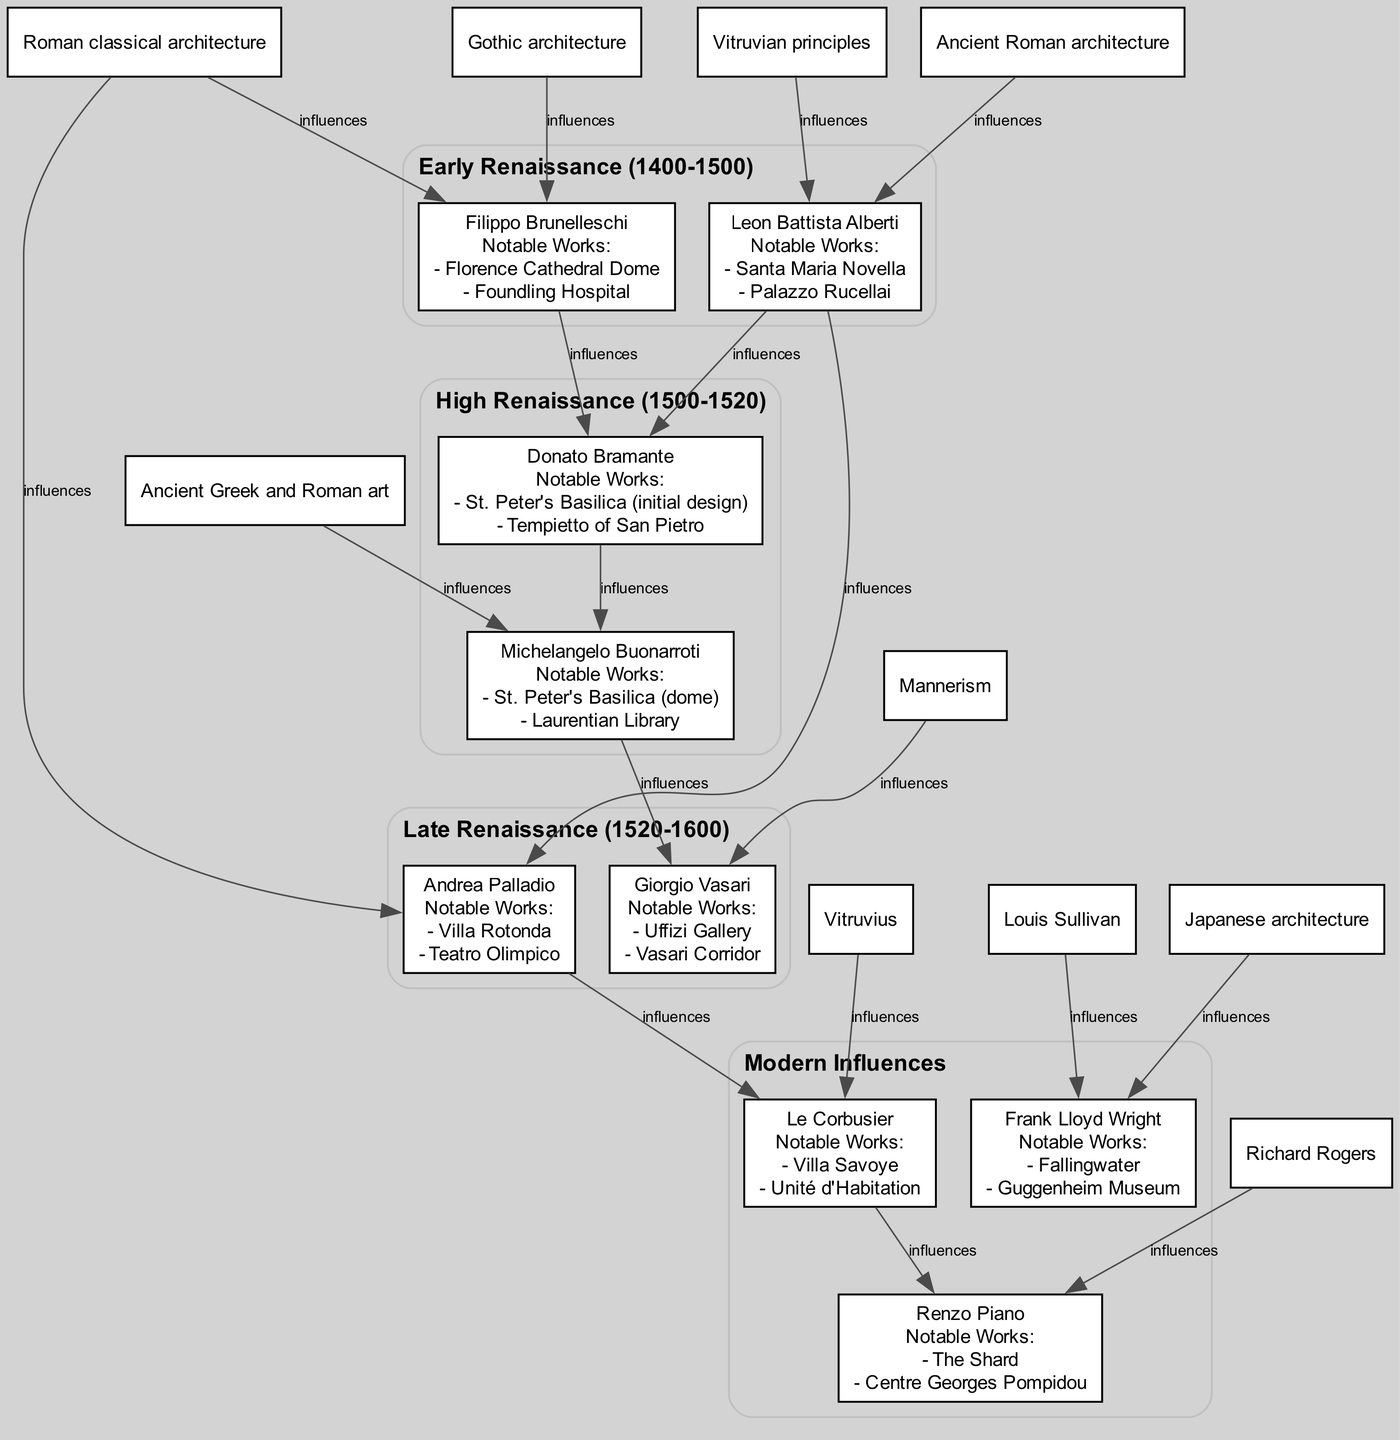What notable work is associated with Filippo Brunelleschi? Filippo Brunelleschi's notable works listed in the diagram are "Florence Cathedral Dome" and "Foundling Hospital". The diagram specifically points out these works under his name.
Answer: Florence Cathedral Dome Which architect from the High Renaissance was influenced by both Brunelleschi and Alberti? The architect Donato Bramante, depicted in the diagram under the High Renaissance generation, clearly shows influences from Filippo Brunelleschi and Leon Battista Alberti. These connections are represented as edges leading to his node.
Answer: Donato Bramante How many architects are listed in the Late Renaissance generation? The Late Renaissance generation in the diagram lists two architects: Andrea Palladio and Giorgio Vasari. By counting these nodes visually in that section, we verify the total.
Answer: 2 Who is noted for the initial design of St. Peter's Basilica? The diagram states that Donato Bramante is noted for the initial design of St. Peter's Basilica. This information can be found directly under his name in the architects' list for the High Renaissance.
Answer: Donato Bramante Which modern architect is influenced by Andrea Palladio? Le Corbusier is recognized in the diagram as being influenced by Andrea Palladio, indicated by an edge connecting his node to Palladio's. This demonstrates the lineage of influence passing through various eras of architects.
Answer: Le Corbusier What generation does Michelangelo Buonarroti belong to? Michelangelo Buonarroti is listed in the High Renaissance generation in the diagram. This is evident as his node is located within the subgraph labeled with the High Renaissance era.
Answer: High Renaissance What works are associated with Giorgio Vasari? The notable works associated with Giorgio Vasari include "Uffizi Gallery" and "Vasari Corridor". These titles are presented clearly under Vasari's name in the diagram.
Answer: Uffizi Gallery, Vasari Corridor Which architect is most influenced by Mannerism? Giorgio Vasari is indicated in the diagram as being influenced by Mannerism. This influence is explicitly outlined in his list of connections.
Answer: Giorgio Vasari Name one notable work of Frank Lloyd Wright. One notable work of Frank Lloyd Wright listed in the diagram is "Fallingwater". This can be retrieved from his node in the Modern Influences section of the diagram.
Answer: Fallingwater 